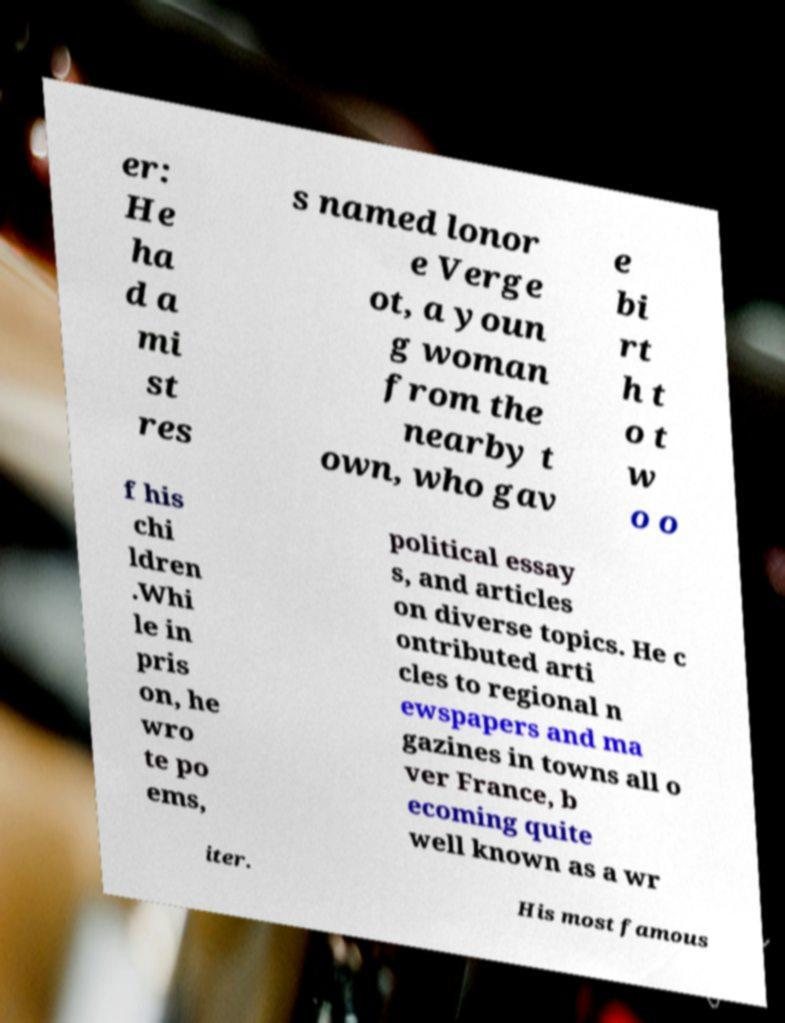I need the written content from this picture converted into text. Can you do that? er: He ha d a mi st res s named lonor e Verge ot, a youn g woman from the nearby t own, who gav e bi rt h t o t w o o f his chi ldren .Whi le in pris on, he wro te po ems, political essay s, and articles on diverse topics. He c ontributed arti cles to regional n ewspapers and ma gazines in towns all o ver France, b ecoming quite well known as a wr iter. His most famous 